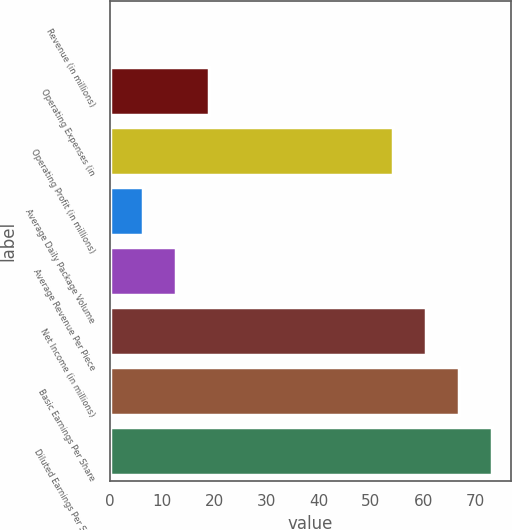Convert chart. <chart><loc_0><loc_0><loc_500><loc_500><bar_chart><fcel>Revenue (in millions)<fcel>Operating Expenses (in<fcel>Operating Profit (in millions)<fcel>Average Daily Package Volume<fcel>Average Revenue Per Piece<fcel>Net Income (in millions)<fcel>Basic Earnings Per Share<fcel>Diluted Earnings Per Share<nl><fcel>0.2<fcel>19.07<fcel>54.3<fcel>6.49<fcel>12.78<fcel>60.59<fcel>66.88<fcel>73.17<nl></chart> 